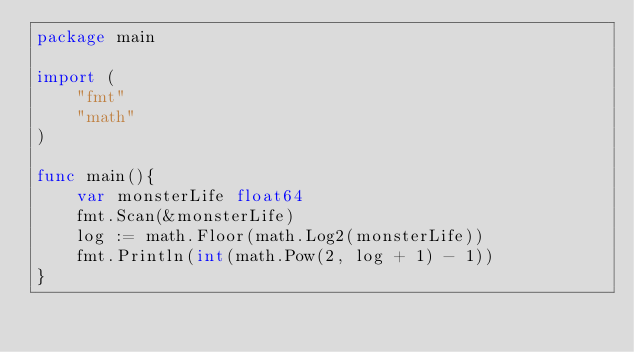<code> <loc_0><loc_0><loc_500><loc_500><_Go_>package main
 
import (
    "fmt"
    "math"
)
 
func main(){
    var monsterLife float64
    fmt.Scan(&monsterLife)
    log := math.Floor(math.Log2(monsterLife))
    fmt.Println(int(math.Pow(2, log + 1) - 1))
}</code> 